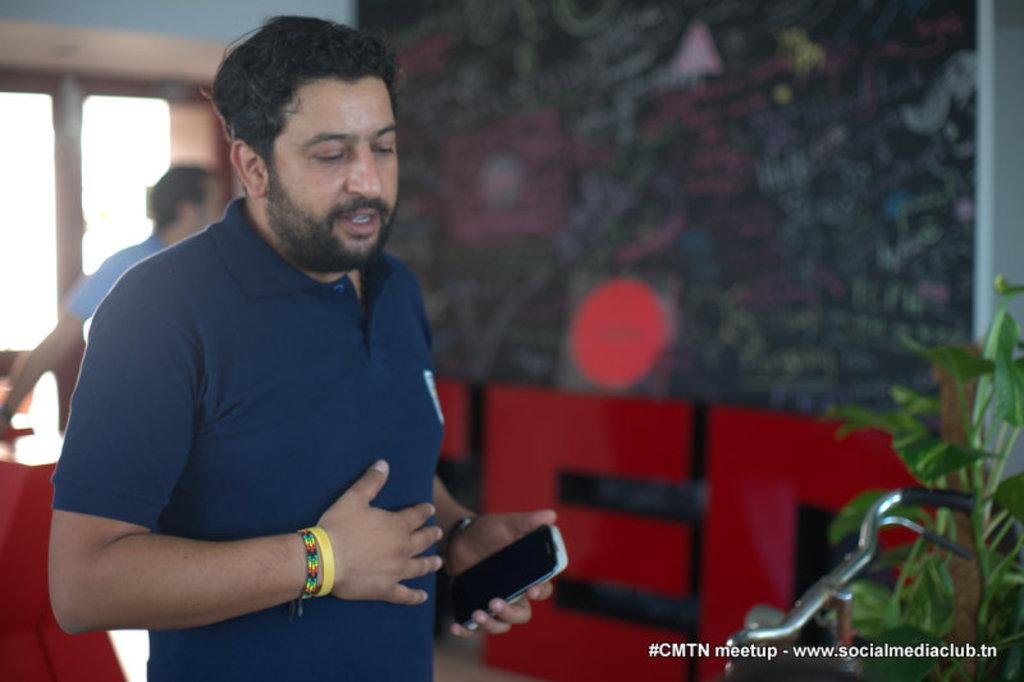What is the man in the image doing? The man is standing in the image and holding a mobile in his hand. Can you describe the other person in the image? There is another person in the image, but their actions or appearance are not specified. What is the condition of the window in the image? The window in the image is closed. What part of a cycle can be seen in the image? There is a cycle handle visible in the image. What type of vegetation is present in the image? There are plants in the image. What type of canvas is the squirrel painting on in the image? There is no squirrel or canvas present in the image. What type of business is being conducted in the image? The image does not depict any business activities or transactions. 